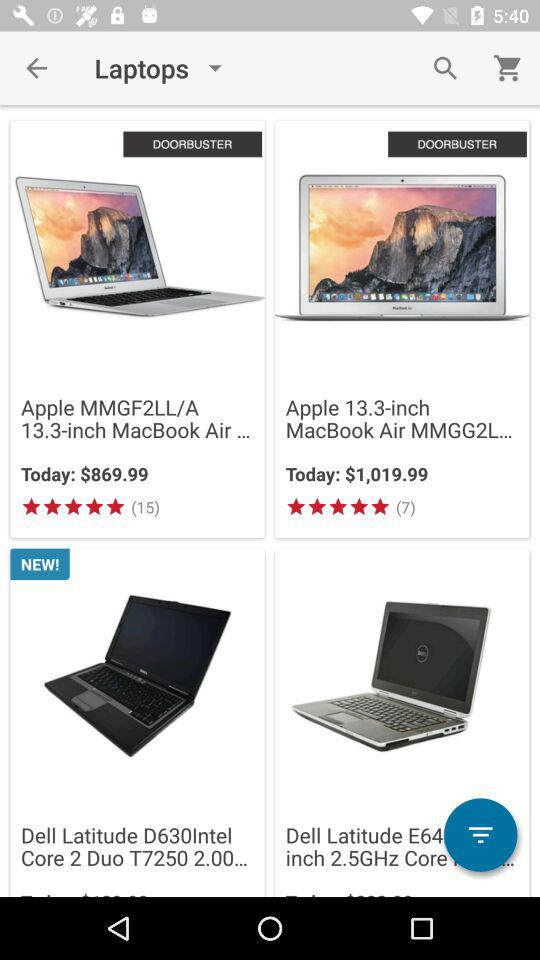How many reviews in total are there for "Apple MMGF2LL/A 13.3-inch MacBook Air"? There are a total of 15 reviews for "Apple MMGF2LL/A 13.3-inch MacBook Air". 